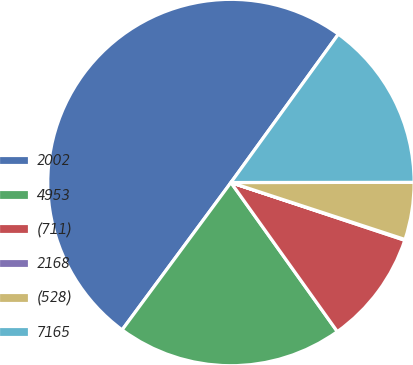<chart> <loc_0><loc_0><loc_500><loc_500><pie_chart><fcel>2002<fcel>4953<fcel>(711)<fcel>2168<fcel>(528)<fcel>7165<nl><fcel>49.85%<fcel>19.99%<fcel>10.03%<fcel>0.07%<fcel>5.05%<fcel>15.01%<nl></chart> 